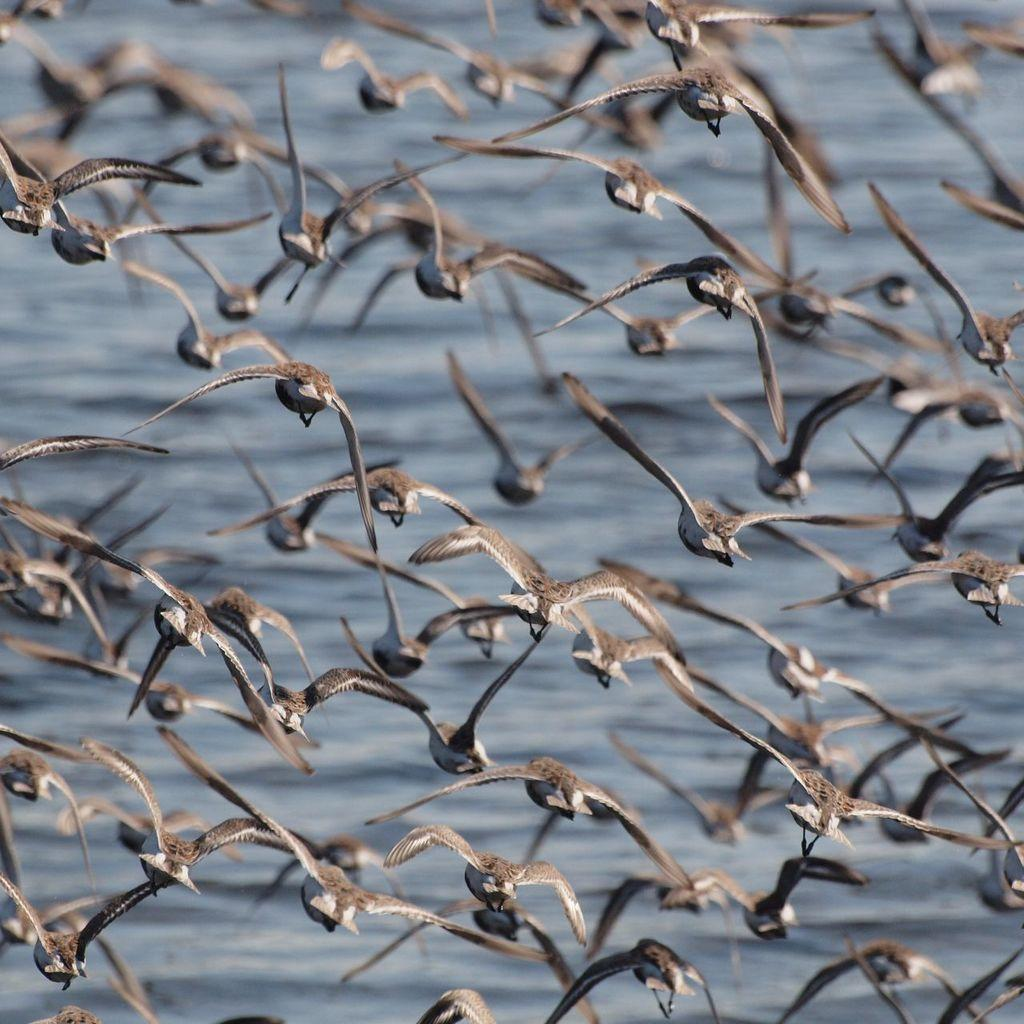What animals are present in the image? There is a group of birds in the image. What are the birds doing in the image? The birds are flying. What natural element can be seen in the image? There is water visible in the image. What type of science experiment can be seen in the image? There is no science experiment present in the image; it features a group of flying birds and water. What type of jeans are the birds wearing in the image? Birds do not wear jeans, so this detail cannot be found in the image. 